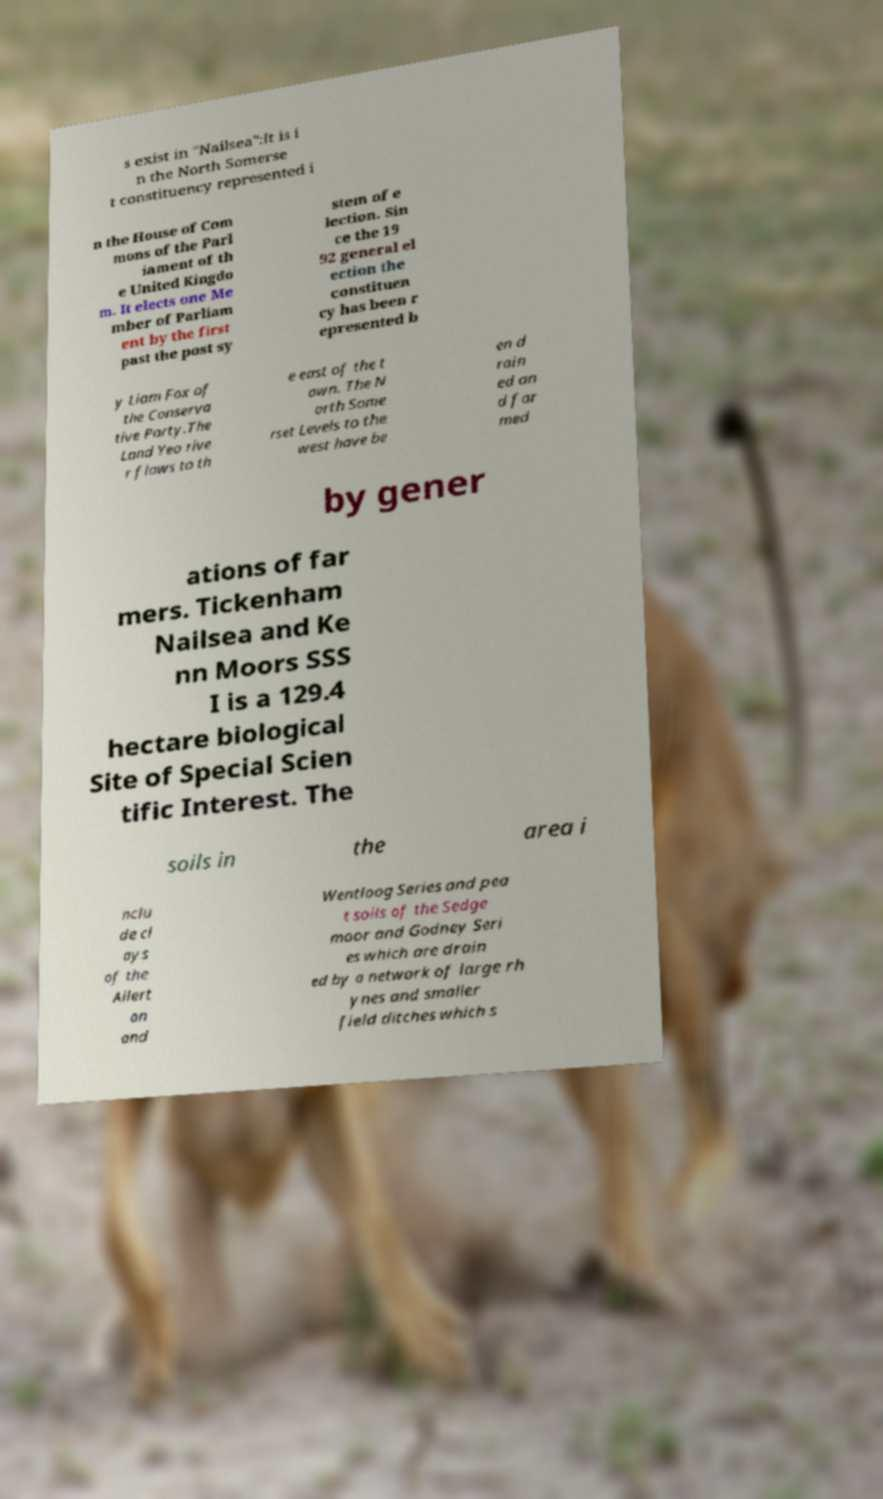There's text embedded in this image that I need extracted. Can you transcribe it verbatim? s exist in "Nailsea":It is i n the North Somerse t constituency represented i n the House of Com mons of the Parl iament of th e United Kingdo m. It elects one Me mber of Parliam ent by the first past the post sy stem of e lection. Sin ce the 19 92 general el ection the constituen cy has been r epresented b y Liam Fox of the Conserva tive Party.The Land Yeo rive r flows to th e east of the t own. The N orth Some rset Levels to the west have be en d rain ed an d far med by gener ations of far mers. Tickenham Nailsea and Ke nn Moors SSS I is a 129.4 hectare biological Site of Special Scien tific Interest. The soils in the area i nclu de cl ays of the Allert on and Wentloog Series and pea t soils of the Sedge moor and Godney Seri es which are drain ed by a network of large rh ynes and smaller field ditches which s 